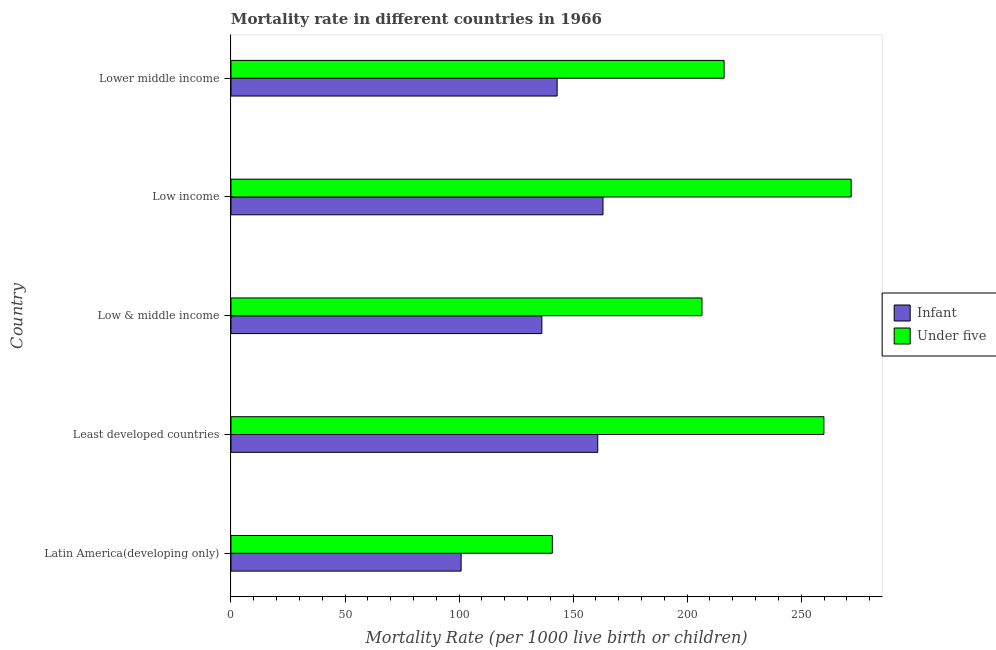How many groups of bars are there?
Give a very brief answer. 5. Are the number of bars per tick equal to the number of legend labels?
Ensure brevity in your answer.  Yes. Are the number of bars on each tick of the Y-axis equal?
Your answer should be very brief. Yes. How many bars are there on the 4th tick from the top?
Your answer should be very brief. 2. What is the label of the 4th group of bars from the top?
Provide a short and direct response. Least developed countries. What is the under-5 mortality rate in Lower middle income?
Make the answer very short. 216.2. Across all countries, what is the maximum infant mortality rate?
Your answer should be compact. 163.1. Across all countries, what is the minimum infant mortality rate?
Your answer should be compact. 100.9. In which country was the infant mortality rate minimum?
Offer a very short reply. Latin America(developing only). What is the total infant mortality rate in the graph?
Your answer should be very brief. 704.1. What is the difference between the infant mortality rate in Latin America(developing only) and that in Least developed countries?
Provide a succinct answer. -59.9. What is the difference between the infant mortality rate in Low & middle income and the under-5 mortality rate in Low income?
Offer a terse response. -135.6. What is the average under-5 mortality rate per country?
Your answer should be very brief. 219.09. What is the ratio of the under-5 mortality rate in Low income to that in Lower middle income?
Make the answer very short. 1.26. Is the difference between the infant mortality rate in Least developed countries and Lower middle income greater than the difference between the under-5 mortality rate in Least developed countries and Lower middle income?
Provide a short and direct response. No. What is the difference between the highest and the second highest infant mortality rate?
Your response must be concise. 2.3. What is the difference between the highest and the lowest infant mortality rate?
Keep it short and to the point. 62.2. In how many countries, is the under-5 mortality rate greater than the average under-5 mortality rate taken over all countries?
Provide a succinct answer. 2. What does the 1st bar from the top in Lower middle income represents?
Your response must be concise. Under five. What does the 1st bar from the bottom in Low & middle income represents?
Ensure brevity in your answer.  Infant. How many bars are there?
Give a very brief answer. 10. Does the graph contain any zero values?
Give a very brief answer. No. Does the graph contain grids?
Offer a very short reply. No. Where does the legend appear in the graph?
Provide a succinct answer. Center right. How many legend labels are there?
Your answer should be compact. 2. How are the legend labels stacked?
Make the answer very short. Vertical. What is the title of the graph?
Keep it short and to the point. Mortality rate in different countries in 1966. Does "RDB concessional" appear as one of the legend labels in the graph?
Offer a terse response. No. What is the label or title of the X-axis?
Your response must be concise. Mortality Rate (per 1000 live birth or children). What is the Mortality Rate (per 1000 live birth or children) in Infant in Latin America(developing only)?
Give a very brief answer. 100.9. What is the Mortality Rate (per 1000 live birth or children) of Under five in Latin America(developing only)?
Provide a short and direct response. 140.9. What is the Mortality Rate (per 1000 live birth or children) in Infant in Least developed countries?
Keep it short and to the point. 160.8. What is the Mortality Rate (per 1000 live birth or children) in Under five in Least developed countries?
Give a very brief answer. 259.96. What is the Mortality Rate (per 1000 live birth or children) in Infant in Low & middle income?
Keep it short and to the point. 136.3. What is the Mortality Rate (per 1000 live birth or children) of Under five in Low & middle income?
Provide a short and direct response. 206.5. What is the Mortality Rate (per 1000 live birth or children) of Infant in Low income?
Your response must be concise. 163.1. What is the Mortality Rate (per 1000 live birth or children) in Under five in Low income?
Your response must be concise. 271.9. What is the Mortality Rate (per 1000 live birth or children) of Infant in Lower middle income?
Keep it short and to the point. 143. What is the Mortality Rate (per 1000 live birth or children) in Under five in Lower middle income?
Keep it short and to the point. 216.2. Across all countries, what is the maximum Mortality Rate (per 1000 live birth or children) of Infant?
Make the answer very short. 163.1. Across all countries, what is the maximum Mortality Rate (per 1000 live birth or children) of Under five?
Give a very brief answer. 271.9. Across all countries, what is the minimum Mortality Rate (per 1000 live birth or children) of Infant?
Your answer should be very brief. 100.9. Across all countries, what is the minimum Mortality Rate (per 1000 live birth or children) of Under five?
Offer a very short reply. 140.9. What is the total Mortality Rate (per 1000 live birth or children) of Infant in the graph?
Your answer should be very brief. 704.1. What is the total Mortality Rate (per 1000 live birth or children) of Under five in the graph?
Ensure brevity in your answer.  1095.46. What is the difference between the Mortality Rate (per 1000 live birth or children) in Infant in Latin America(developing only) and that in Least developed countries?
Offer a terse response. -59.9. What is the difference between the Mortality Rate (per 1000 live birth or children) of Under five in Latin America(developing only) and that in Least developed countries?
Offer a terse response. -119.06. What is the difference between the Mortality Rate (per 1000 live birth or children) in Infant in Latin America(developing only) and that in Low & middle income?
Make the answer very short. -35.4. What is the difference between the Mortality Rate (per 1000 live birth or children) of Under five in Latin America(developing only) and that in Low & middle income?
Ensure brevity in your answer.  -65.6. What is the difference between the Mortality Rate (per 1000 live birth or children) in Infant in Latin America(developing only) and that in Low income?
Ensure brevity in your answer.  -62.2. What is the difference between the Mortality Rate (per 1000 live birth or children) in Under five in Latin America(developing only) and that in Low income?
Your answer should be compact. -131. What is the difference between the Mortality Rate (per 1000 live birth or children) in Infant in Latin America(developing only) and that in Lower middle income?
Your answer should be very brief. -42.1. What is the difference between the Mortality Rate (per 1000 live birth or children) of Under five in Latin America(developing only) and that in Lower middle income?
Give a very brief answer. -75.3. What is the difference between the Mortality Rate (per 1000 live birth or children) in Infant in Least developed countries and that in Low & middle income?
Provide a succinct answer. 24.5. What is the difference between the Mortality Rate (per 1000 live birth or children) of Under five in Least developed countries and that in Low & middle income?
Your answer should be compact. 53.46. What is the difference between the Mortality Rate (per 1000 live birth or children) in Infant in Least developed countries and that in Low income?
Provide a short and direct response. -2.3. What is the difference between the Mortality Rate (per 1000 live birth or children) in Under five in Least developed countries and that in Low income?
Keep it short and to the point. -11.94. What is the difference between the Mortality Rate (per 1000 live birth or children) of Infant in Least developed countries and that in Lower middle income?
Keep it short and to the point. 17.8. What is the difference between the Mortality Rate (per 1000 live birth or children) in Under five in Least developed countries and that in Lower middle income?
Make the answer very short. 43.76. What is the difference between the Mortality Rate (per 1000 live birth or children) of Infant in Low & middle income and that in Low income?
Ensure brevity in your answer.  -26.8. What is the difference between the Mortality Rate (per 1000 live birth or children) in Under five in Low & middle income and that in Low income?
Make the answer very short. -65.4. What is the difference between the Mortality Rate (per 1000 live birth or children) in Infant in Low & middle income and that in Lower middle income?
Your response must be concise. -6.7. What is the difference between the Mortality Rate (per 1000 live birth or children) in Under five in Low & middle income and that in Lower middle income?
Your answer should be compact. -9.7. What is the difference between the Mortality Rate (per 1000 live birth or children) of Infant in Low income and that in Lower middle income?
Give a very brief answer. 20.1. What is the difference between the Mortality Rate (per 1000 live birth or children) of Under five in Low income and that in Lower middle income?
Give a very brief answer. 55.7. What is the difference between the Mortality Rate (per 1000 live birth or children) of Infant in Latin America(developing only) and the Mortality Rate (per 1000 live birth or children) of Under five in Least developed countries?
Your answer should be compact. -159.06. What is the difference between the Mortality Rate (per 1000 live birth or children) in Infant in Latin America(developing only) and the Mortality Rate (per 1000 live birth or children) in Under five in Low & middle income?
Keep it short and to the point. -105.6. What is the difference between the Mortality Rate (per 1000 live birth or children) in Infant in Latin America(developing only) and the Mortality Rate (per 1000 live birth or children) in Under five in Low income?
Provide a short and direct response. -171. What is the difference between the Mortality Rate (per 1000 live birth or children) of Infant in Latin America(developing only) and the Mortality Rate (per 1000 live birth or children) of Under five in Lower middle income?
Give a very brief answer. -115.3. What is the difference between the Mortality Rate (per 1000 live birth or children) of Infant in Least developed countries and the Mortality Rate (per 1000 live birth or children) of Under five in Low & middle income?
Offer a very short reply. -45.7. What is the difference between the Mortality Rate (per 1000 live birth or children) of Infant in Least developed countries and the Mortality Rate (per 1000 live birth or children) of Under five in Low income?
Provide a short and direct response. -111.1. What is the difference between the Mortality Rate (per 1000 live birth or children) of Infant in Least developed countries and the Mortality Rate (per 1000 live birth or children) of Under five in Lower middle income?
Provide a short and direct response. -55.4. What is the difference between the Mortality Rate (per 1000 live birth or children) of Infant in Low & middle income and the Mortality Rate (per 1000 live birth or children) of Under five in Low income?
Offer a terse response. -135.6. What is the difference between the Mortality Rate (per 1000 live birth or children) in Infant in Low & middle income and the Mortality Rate (per 1000 live birth or children) in Under five in Lower middle income?
Your answer should be compact. -79.9. What is the difference between the Mortality Rate (per 1000 live birth or children) in Infant in Low income and the Mortality Rate (per 1000 live birth or children) in Under five in Lower middle income?
Provide a short and direct response. -53.1. What is the average Mortality Rate (per 1000 live birth or children) in Infant per country?
Provide a succinct answer. 140.82. What is the average Mortality Rate (per 1000 live birth or children) in Under five per country?
Provide a short and direct response. 219.09. What is the difference between the Mortality Rate (per 1000 live birth or children) in Infant and Mortality Rate (per 1000 live birth or children) in Under five in Least developed countries?
Offer a terse response. -99.16. What is the difference between the Mortality Rate (per 1000 live birth or children) in Infant and Mortality Rate (per 1000 live birth or children) in Under five in Low & middle income?
Provide a succinct answer. -70.2. What is the difference between the Mortality Rate (per 1000 live birth or children) in Infant and Mortality Rate (per 1000 live birth or children) in Under five in Low income?
Ensure brevity in your answer.  -108.8. What is the difference between the Mortality Rate (per 1000 live birth or children) of Infant and Mortality Rate (per 1000 live birth or children) of Under five in Lower middle income?
Give a very brief answer. -73.2. What is the ratio of the Mortality Rate (per 1000 live birth or children) in Infant in Latin America(developing only) to that in Least developed countries?
Keep it short and to the point. 0.63. What is the ratio of the Mortality Rate (per 1000 live birth or children) in Under five in Latin America(developing only) to that in Least developed countries?
Your response must be concise. 0.54. What is the ratio of the Mortality Rate (per 1000 live birth or children) of Infant in Latin America(developing only) to that in Low & middle income?
Offer a very short reply. 0.74. What is the ratio of the Mortality Rate (per 1000 live birth or children) of Under five in Latin America(developing only) to that in Low & middle income?
Your answer should be compact. 0.68. What is the ratio of the Mortality Rate (per 1000 live birth or children) of Infant in Latin America(developing only) to that in Low income?
Offer a terse response. 0.62. What is the ratio of the Mortality Rate (per 1000 live birth or children) in Under five in Latin America(developing only) to that in Low income?
Give a very brief answer. 0.52. What is the ratio of the Mortality Rate (per 1000 live birth or children) of Infant in Latin America(developing only) to that in Lower middle income?
Your answer should be compact. 0.71. What is the ratio of the Mortality Rate (per 1000 live birth or children) of Under five in Latin America(developing only) to that in Lower middle income?
Offer a terse response. 0.65. What is the ratio of the Mortality Rate (per 1000 live birth or children) of Infant in Least developed countries to that in Low & middle income?
Provide a short and direct response. 1.18. What is the ratio of the Mortality Rate (per 1000 live birth or children) in Under five in Least developed countries to that in Low & middle income?
Your answer should be compact. 1.26. What is the ratio of the Mortality Rate (per 1000 live birth or children) in Infant in Least developed countries to that in Low income?
Your response must be concise. 0.99. What is the ratio of the Mortality Rate (per 1000 live birth or children) in Under five in Least developed countries to that in Low income?
Give a very brief answer. 0.96. What is the ratio of the Mortality Rate (per 1000 live birth or children) of Infant in Least developed countries to that in Lower middle income?
Make the answer very short. 1.12. What is the ratio of the Mortality Rate (per 1000 live birth or children) in Under five in Least developed countries to that in Lower middle income?
Provide a succinct answer. 1.2. What is the ratio of the Mortality Rate (per 1000 live birth or children) in Infant in Low & middle income to that in Low income?
Ensure brevity in your answer.  0.84. What is the ratio of the Mortality Rate (per 1000 live birth or children) of Under five in Low & middle income to that in Low income?
Ensure brevity in your answer.  0.76. What is the ratio of the Mortality Rate (per 1000 live birth or children) of Infant in Low & middle income to that in Lower middle income?
Ensure brevity in your answer.  0.95. What is the ratio of the Mortality Rate (per 1000 live birth or children) of Under five in Low & middle income to that in Lower middle income?
Ensure brevity in your answer.  0.96. What is the ratio of the Mortality Rate (per 1000 live birth or children) in Infant in Low income to that in Lower middle income?
Your response must be concise. 1.14. What is the ratio of the Mortality Rate (per 1000 live birth or children) of Under five in Low income to that in Lower middle income?
Ensure brevity in your answer.  1.26. What is the difference between the highest and the second highest Mortality Rate (per 1000 live birth or children) in Infant?
Provide a short and direct response. 2.3. What is the difference between the highest and the second highest Mortality Rate (per 1000 live birth or children) in Under five?
Your answer should be very brief. 11.94. What is the difference between the highest and the lowest Mortality Rate (per 1000 live birth or children) in Infant?
Your response must be concise. 62.2. What is the difference between the highest and the lowest Mortality Rate (per 1000 live birth or children) in Under five?
Give a very brief answer. 131. 